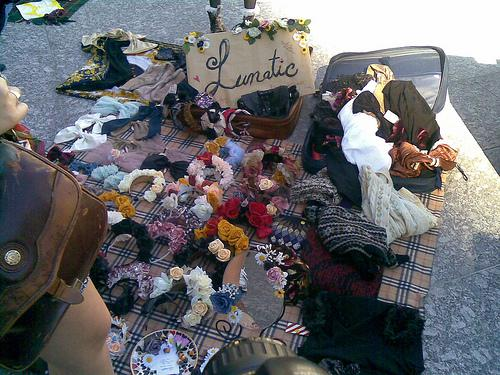Question: how many suitcases are there?
Choices:
A. One.
B. Three.
C. Two.
D. Four.
Answer with the letter. Answer: C Question: where are the flowers?
Choices:
A. In vases.
B. In flower cart.
C. On the headbands and the sign.
D. In the garden.
Answer with the letter. Answer: C Question: what is on the blanket?
Choices:
A. Hair accessories, a mirror, cloth and suitcases.
B. Cat,kitten,girls and boys.
C. Baby,bottle,diapers and powder.
D. Girls,dolls,comb and brush.
Answer with the letter. Answer: A Question: where is the blanket?
Choices:
A. On the ground.
B. On the bed.
C. In the car.
D. On the sand.
Answer with the letter. Answer: A Question: who is standing at the far left?
Choices:
A. A dog.
B. The teacher.
C. A person.
D. A friend.
Answer with the letter. Answer: C Question: what does the sign say?
Choices:
A. Free.
B. Danger.
C. Lunatic.
D. Stop.
Answer with the letter. Answer: C 